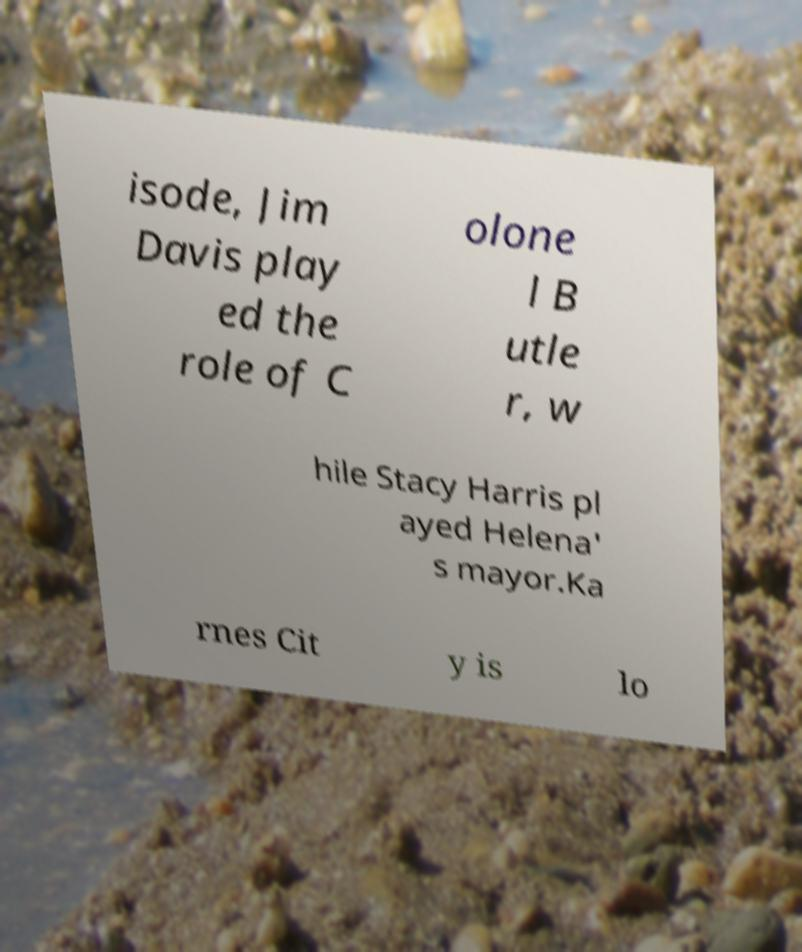What messages or text are displayed in this image? I need them in a readable, typed format. isode, Jim Davis play ed the role of C olone l B utle r, w hile Stacy Harris pl ayed Helena' s mayor.Ka rnes Cit y is lo 